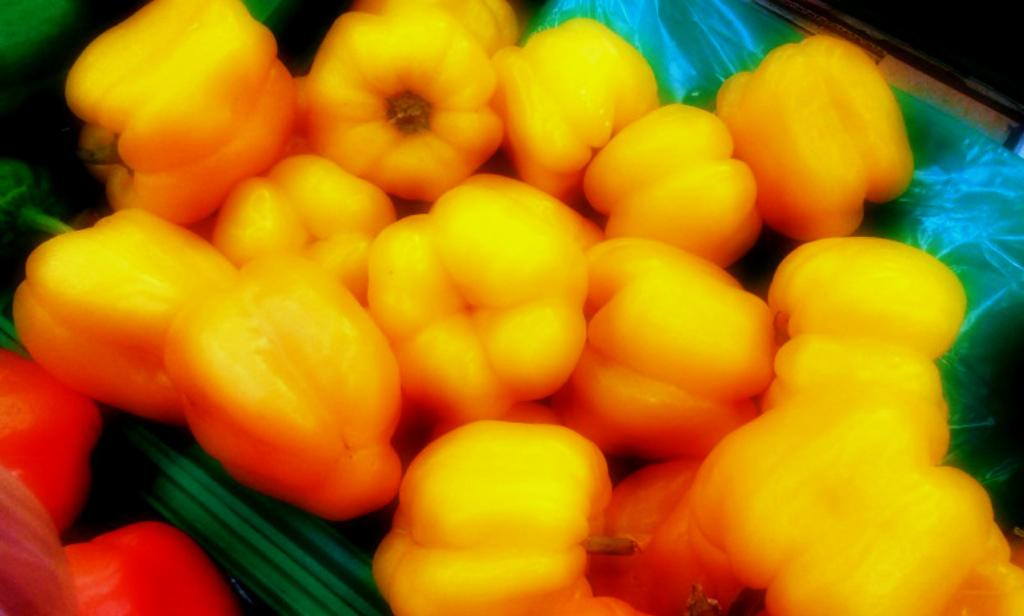What type of vegetables are in the image? There are capsicums in the image. What color are the capsicums? The capsicums are in yellow color. What is the background of the capsicums in the image? The capsicums are on a blue and green color sheet. What type of business is being conducted in the image? There is no indication of any business activity in the image; it features capsicums on a sheet. What is the chalk used for in the image? There is no chalk present in the image. 